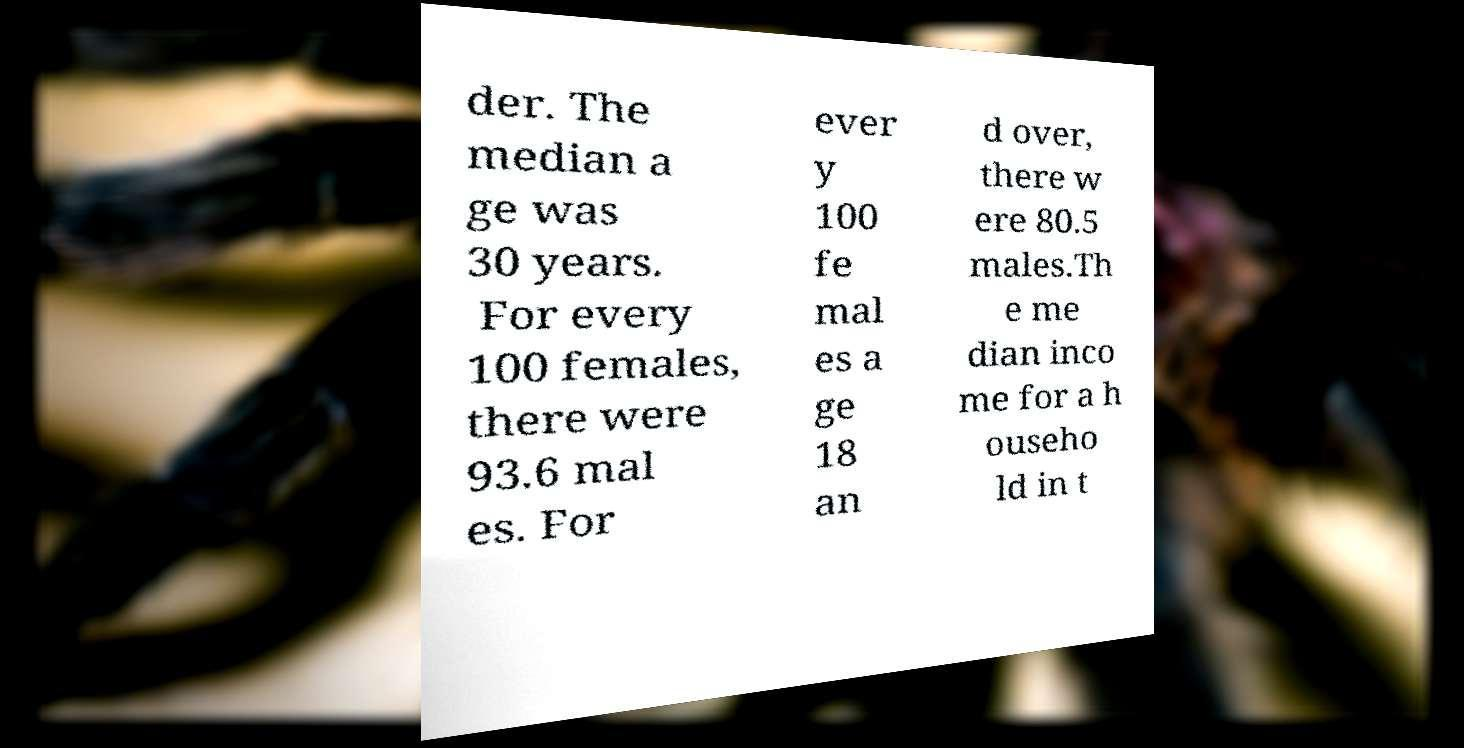There's text embedded in this image that I need extracted. Can you transcribe it verbatim? der. The median a ge was 30 years. For every 100 females, there were 93.6 mal es. For ever y 100 fe mal es a ge 18 an d over, there w ere 80.5 males.Th e me dian inco me for a h ouseho ld in t 